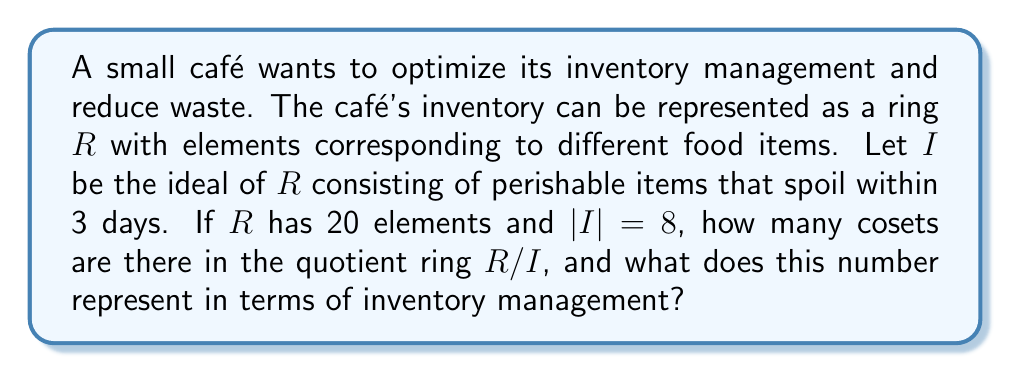Teach me how to tackle this problem. To solve this problem, we need to apply the concept of ideals and quotient rings in the context of inventory management. Let's break it down step-by-step:

1) In ring theory, an ideal $I$ of a ring $R$ is a subring of $R$ that absorbs multiplication by elements of $R$. In this case, $I$ represents the perishable items that spoil within 3 days.

2) The quotient ring $R/I$ is the set of all cosets of $I$ in $R$. Each coset represents a class of items that are equivalent modulo the ideal $I$.

3) The number of cosets in $R/I$ is equal to the index of $I$ in $R$, which is calculated as:

   $[R:I] = \frac{|R|}{|I|}$

   Where $|R|$ is the number of elements in $R$, and $|I|$ is the number of elements in $I$.

4) Given:
   $|R| = 20$ (total number of food items)
   $|I| = 8$ (number of perishable items that spoil within 3 days)

5) Calculating the number of cosets:

   $[R:I] = \frac{|R|}{|I|} = \frac{20}{8} = \frac{5}{2} = 2.5$

6) However, since the number of cosets must be an integer, we round up to the nearest whole number: 3 cosets.

In terms of inventory management, these 3 cosets represent:
a) Perishable items (the ideal $I$ itself)
b) Non-perishable items
c) Items that are partially perishable or have a longer shelf life

This classification helps the café owner to optimize inventory by treating each category differently, thereby reducing waste and improving efficiency.
Answer: There are 3 cosets in the quotient ring $R/I$, representing three distinct categories of items in the café's inventory management system: perishable items, non-perishable items, and items with intermediate shelf life. 